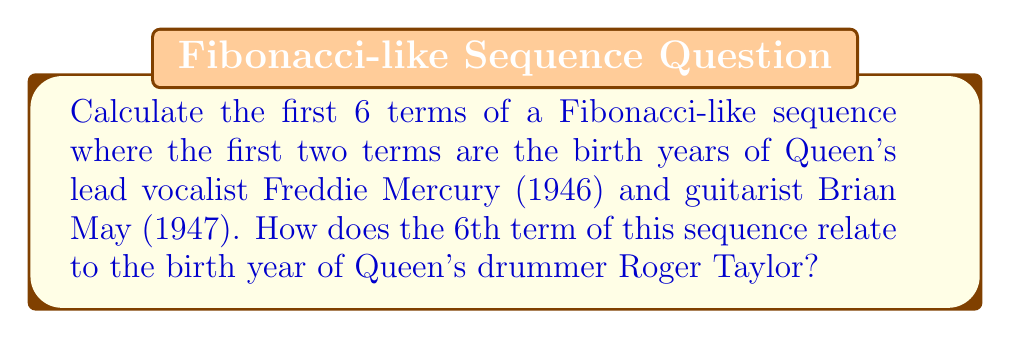Show me your answer to this math problem. Let's approach this step-by-step:

1) The Fibonacci-like sequence starts with the birth years of Freddie Mercury and Brian May:
   $a_1 = 1946$ (Freddie Mercury's birth year)
   $a_2 = 1947$ (Brian May's birth year)

2) For a Fibonacci-like sequence, each subsequent term is the sum of the two preceding ones:
   $a_n = a_{n-1} + a_{n-2}$ for $n \geq 3$

3) Let's calculate the next 4 terms:

   $a_3 = a_2 + a_1 = 1947 + 1946 = 3893$
   
   $a_4 = a_3 + a_2 = 3893 + 1947 = 5840$
   
   $a_5 = a_4 + a_3 = 5840 + 3893 = 9733$
   
   $a_6 = a_5 + a_4 = 9733 + 5840 = 15573$

4) The complete sequence of 6 terms is:
   1946, 1947, 3893, 5840, 9733, 15573

5) Roger Taylor, Queen's drummer, was born in 1949.

6) The difference between the 6th term and Roger Taylor's birth year:
   $15573 - 1949 = 13624$

Therefore, the 6th term of the sequence (15573) is 13624 years after Roger Taylor's birth year.
Answer: 13624 years after Roger Taylor's birth year 